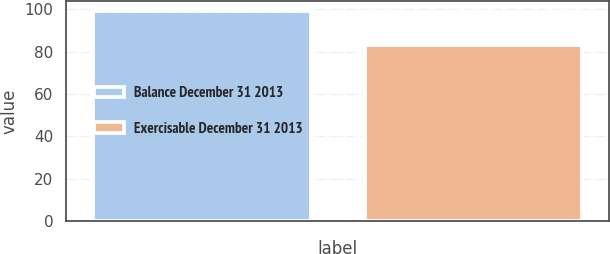<chart> <loc_0><loc_0><loc_500><loc_500><bar_chart><fcel>Balance December 31 2013<fcel>Exercisable December 31 2013<nl><fcel>99<fcel>83<nl></chart> 